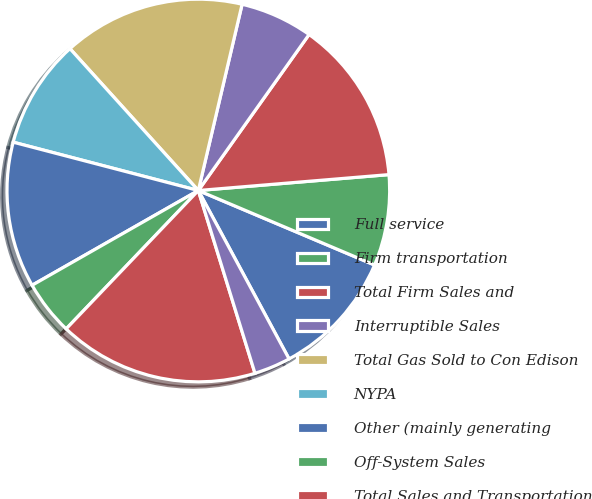<chart> <loc_0><loc_0><loc_500><loc_500><pie_chart><fcel>Full service<fcel>Firm transportation<fcel>Total Firm Sales and<fcel>Interruptible Sales<fcel>Total Gas Sold to Con Edison<fcel>NYPA<fcel>Other (mainly generating<fcel>Off-System Sales<fcel>Total Sales and Transportation<fcel>Other operating revenues<nl><fcel>10.77%<fcel>7.69%<fcel>13.85%<fcel>6.15%<fcel>15.38%<fcel>9.23%<fcel>12.31%<fcel>4.62%<fcel>16.92%<fcel>3.08%<nl></chart> 